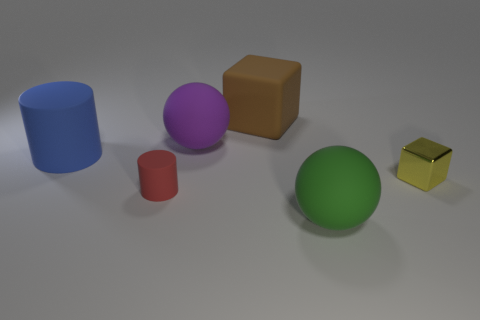There is a tiny thing that is on the right side of the large brown block; what is its shape?
Offer a terse response. Cube. The cylinder that is the same size as the brown thing is what color?
Offer a very short reply. Blue. There is a large green matte object; is its shape the same as the small yellow metal thing in front of the brown rubber object?
Ensure brevity in your answer.  No. What is the sphere that is behind the tiny thing that is on the left side of the block left of the yellow cube made of?
Your answer should be very brief. Rubber. How many big things are matte spheres or purple things?
Make the answer very short. 2. What number of other things are there of the same size as the brown matte thing?
Provide a succinct answer. 3. Is the shape of the rubber thing on the left side of the small cylinder the same as  the brown rubber thing?
Offer a terse response. No. What color is the large matte object that is the same shape as the small rubber thing?
Keep it short and to the point. Blue. Are there any other things that have the same shape as the purple matte thing?
Give a very brief answer. Yes. Is the number of large things that are behind the shiny thing the same as the number of tiny red rubber spheres?
Your answer should be compact. No. 